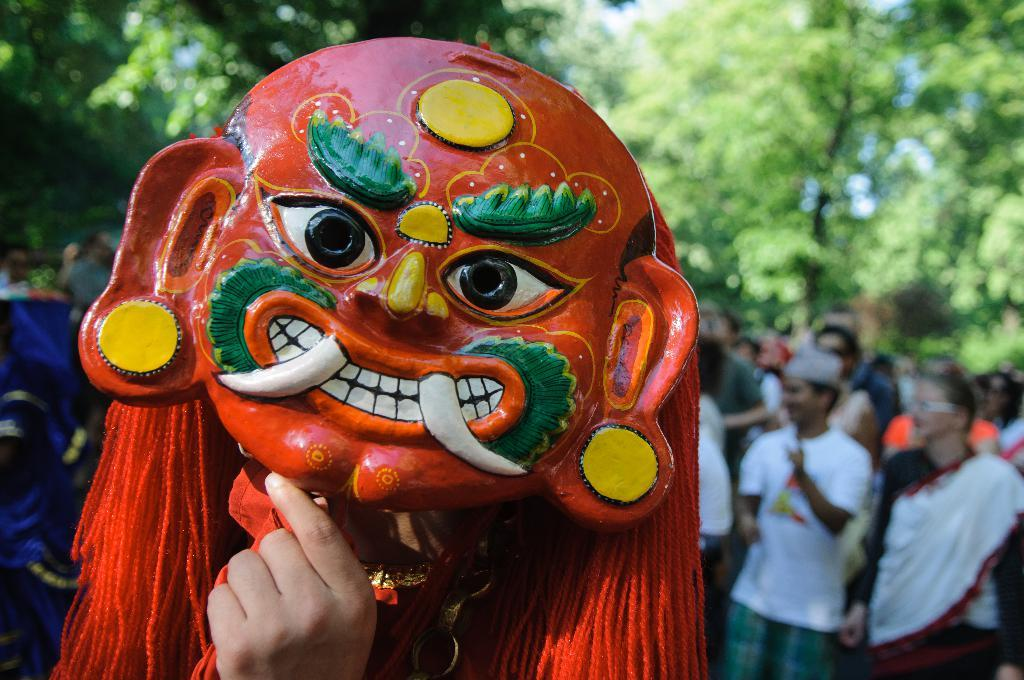What type of natural elements can be seen in the image? There are trees in the image. Are there any human subjects in the image? Yes, there are people in the image. What protective gear is visible on the people in the image? Face masks are present in the image. Can you see any ants climbing up the trees in the image? There are no ants visible in the image; it only features trees and people wearing face masks. 